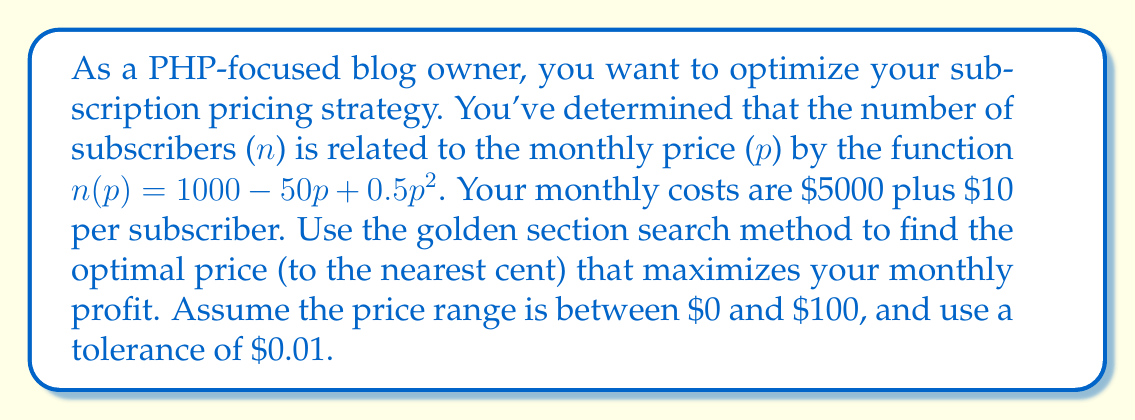Help me with this question. Let's approach this step-by-step:

1) First, we need to define our profit function. Profit is revenue minus costs:
   $\text{Profit}(p) = pn(p) - (5000 + 10n(p))$
   $= p(1000 - 50p + 0.5p^2) - (5000 + 10(1000 - 50p + 0.5p^2))$
   $= 1000p - 50p^2 + 0.5p^3 - 5000 - 10000 + 500p - 5p^2$
   $= 0.5p^3 - 55p^2 + 1500p - 15000$

2) The golden section search method is used to find the maximum of this function.

3) The golden ratio is $\phi = \frac{\sqrt{5}-1}{2} \approx 0.618034$

4) We start with the interval $[a,b] = [0,100]$

5) We calculate two intermediate points:
   $x_1 = b - \phi(b-a) = 100 - 0.618034(100-0) = 38.1966$
   $x_2 = a + \phi(b-a) = 0 + 0.618034(100-0) = 61.8034$

6) We evaluate the function at these points:
   $f(x_1) = f(38.1966) \approx 14,205.75$
   $f(x_2) = f(61.8034) \approx 13,205.75$

7) Since $f(x_1) > f(x_2)$, we know the maximum is in the interval $[a,x_2]$, so we update $b = x_2$

8) We repeat steps 5-7, narrowing the interval each time, until the interval is smaller than our tolerance of $0.01$

9) After several iterations, we converge to the interval $[38.46, 38.47]$

10) Taking the midpoint of this interval gives us our optimal price: $38.465$

11) Rounding to the nearest cent gives us $\$38.47$
Answer: $\$38.47$ 